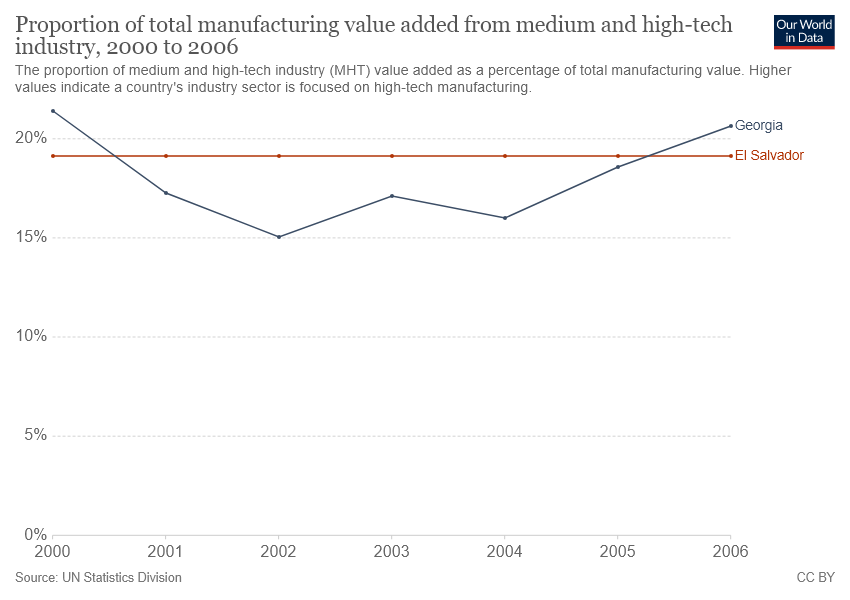List a handful of essential elements in this visual. The proportion of total manufacturing value in Georgia in 2002 was close to 15%, which indicates that manufacturing was an important sector of the economy. In six years, the value of the Georgia graph will be greater than 15. 